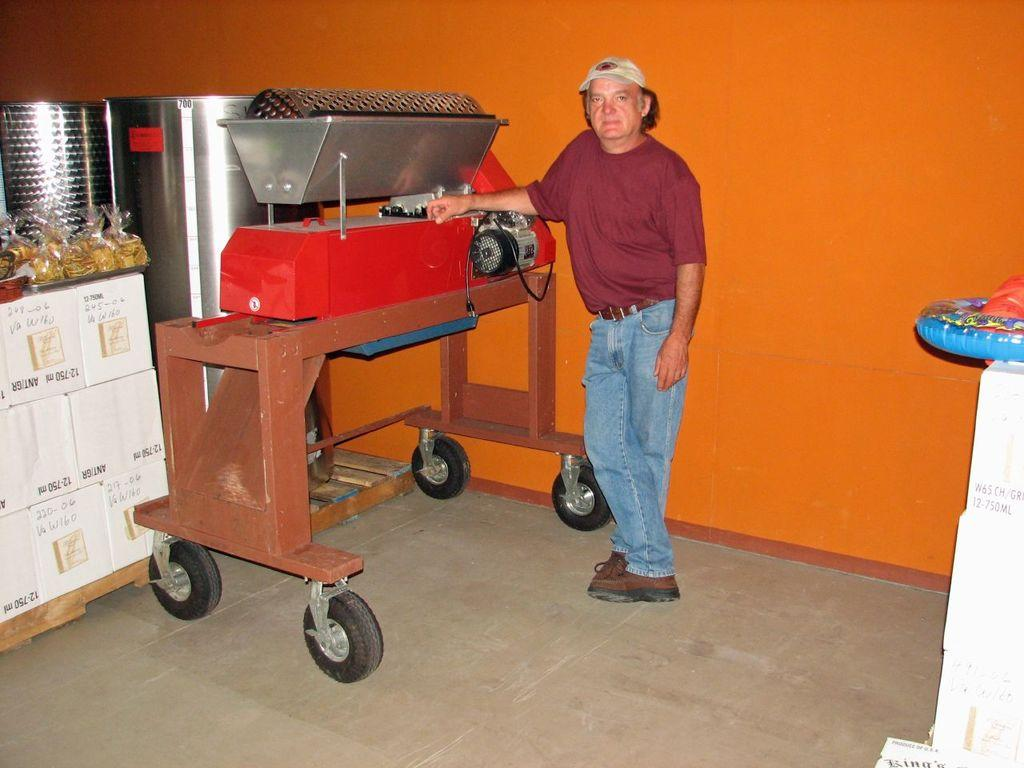Who is present in the image? There is a man in the image. What is the table in the image like? The table in the image has wheels. What is located above the table? An electrical machine is above the table. What can be found on the table? Food packets are on the table. What type of containers are in the image? There are containers in the image. What color is the wall in the image? The wall is orange in color. How many feet does the man have in the image? The number of feet the man has cannot be determined from the image. What type of throat condition does the man have in the image? There is no information about the man's throat condition in the image. 